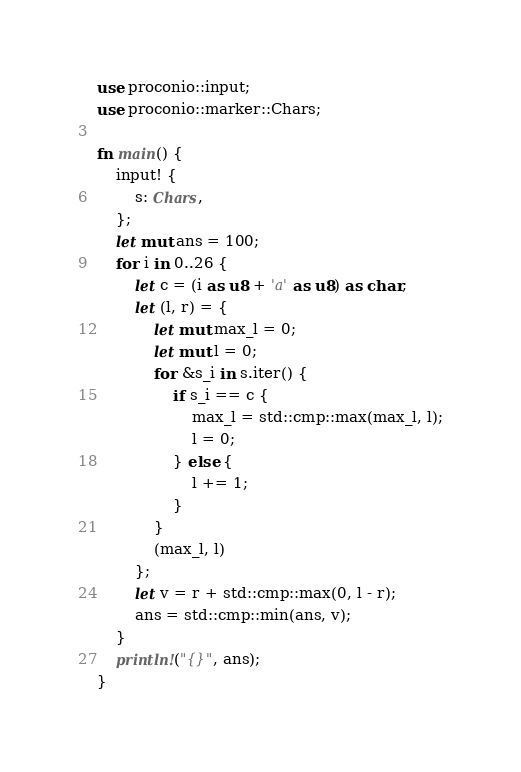<code> <loc_0><loc_0><loc_500><loc_500><_Rust_>use proconio::input;
use proconio::marker::Chars;

fn main() {
    input! {
        s: Chars,
    };
    let mut ans = 100;
    for i in 0..26 {
        let c = (i as u8 + 'a' as u8) as char;
        let (l, r) = {
            let mut max_l = 0;
            let mut l = 0;
            for &s_i in s.iter() {
                if s_i == c {
                    max_l = std::cmp::max(max_l, l);
                    l = 0;
                } else {
                    l += 1;
                }
            }
            (max_l, l)
        };
        let v = r + std::cmp::max(0, l - r);
        ans = std::cmp::min(ans, v);
    }
    println!("{}", ans);
}
</code> 